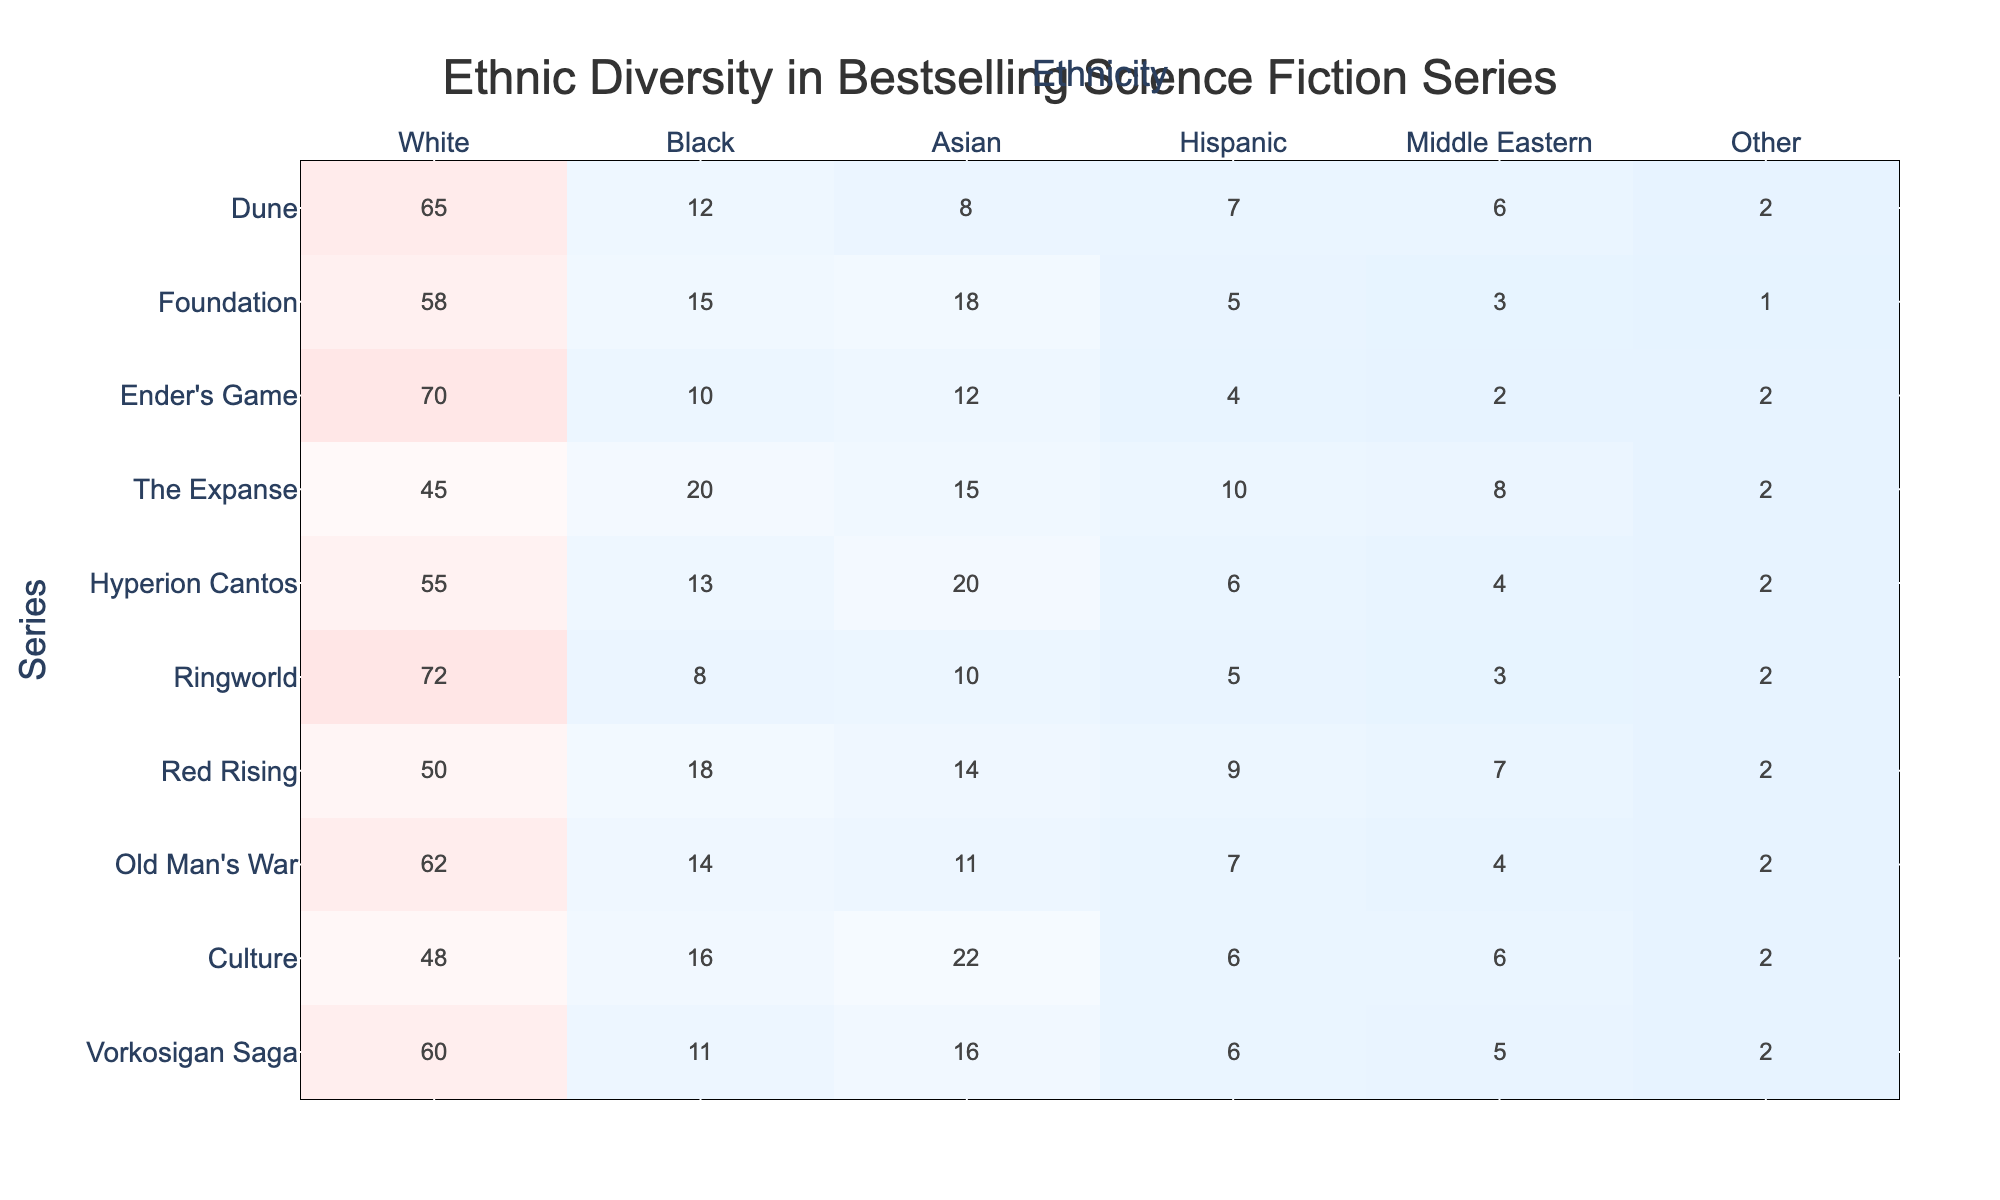What is the percentage of White characters in the series "Dune"? In the table, "Dune" has 65 White characters. To find the percentage, we consider the total characters, which is 100. Thus, the percentage is simply 65%.
Answer: 65% What series has the highest percentage of Asian characters? The series with the highest percentage of Asian characters is "Hyperion Cantos", which has 20 Asian characters, the maximum value in that column.
Answer: Hyperion Cantos How many more Black characters are there in "The Expanse" than in "Foundation"? "The Expanse" has 20 Black characters while "Foundation" has 15. The difference can be calculated as 20 - 15 = 5.
Answer: 5 What is the total number of characters labeled as "Other" across all series? The total number of characters labeled as "Other" is calculated by summing the "Other" column: 2 + 1 + 2 + 2 + 2 + 2 + 2 + 2 + 2 + 2 = 20.
Answer: 20 Is the number of Hispanic characters in "Red Rising" greater than in "Ender's Game"? "Red Rising" has 9 Hispanic characters and "Ender's Game" has 4. Since 9 is greater than 4, the statement is true.
Answer: Yes Which series has the fewest Middle Eastern characters, and how many are there? The series with the fewest Middle Eastern characters is "Foundation" with just 3 characters. This is the lowest value listed in that column.
Answer: Foundation, 3 What is the average percentage of White characters across all series? To find the average, sum the White percentages (65 + 58 + 70 + 45 + 55 + 72 + 50 + 62 + 48 + 60 =  615) and divide by the number of series (10), resulting in an average of 61.5%.
Answer: 61.5% Are there more characters in "Hyperion Cantos" than in "Ringworld"? "Hyperion Cantos" has a total of 55+13+20+6+4+2 = 100 characters, while "Ringworld" has 72+8+10+5+3+2 = 100 characters. Therefore, they have the same number of characters.
Answer: No Which series has the most diverse character names with the highest representation in multiple categories? "The Expanse" shows varied numbers across most categories: 45 White, 20 Black, 15 Asian, 10 Hispanic, and 8 Middle Eastern. Given its representation, it appears most diverse among the options.
Answer: The Expanse What is the difference in the number of White characters between the series "Dune" and "Old Man's War"? "Dune" has 65 White characters, and "Old Man's War" has 62. The difference is calculated as 65 - 62 = 3.
Answer: 3 